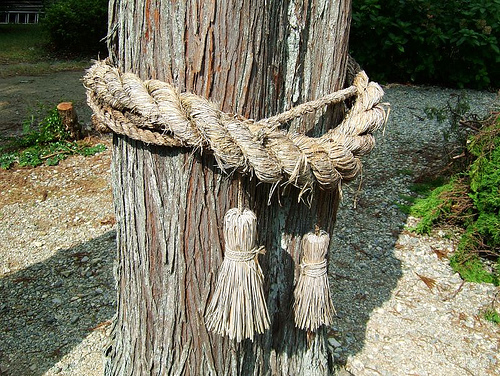<image>
Is the thread on the tree? Yes. Looking at the image, I can see the thread is positioned on top of the tree, with the tree providing support. Is the rope on the ground? No. The rope is not positioned on the ground. They may be near each other, but the rope is not supported by or resting on top of the ground. 